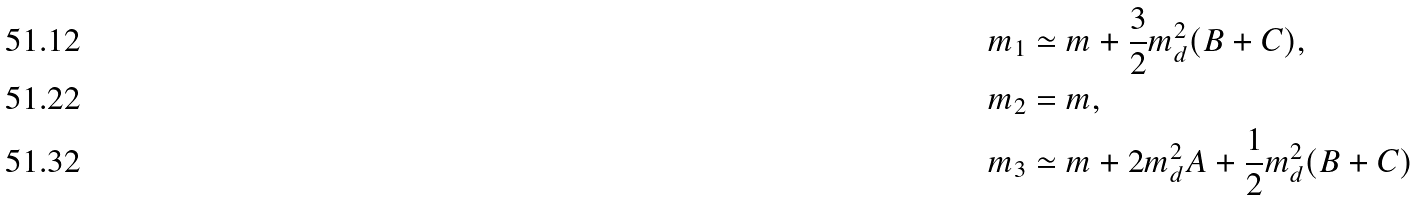<formula> <loc_0><loc_0><loc_500><loc_500>m _ { 1 } & \simeq m + \frac { 3 } { 2 } m _ { d } ^ { 2 } ( B + C ) , \\ m _ { 2 } & = m , \\ m _ { 3 } & \simeq m + 2 m _ { d } ^ { 2 } A + \frac { 1 } { 2 } m _ { d } ^ { 2 } ( B + C )</formula> 